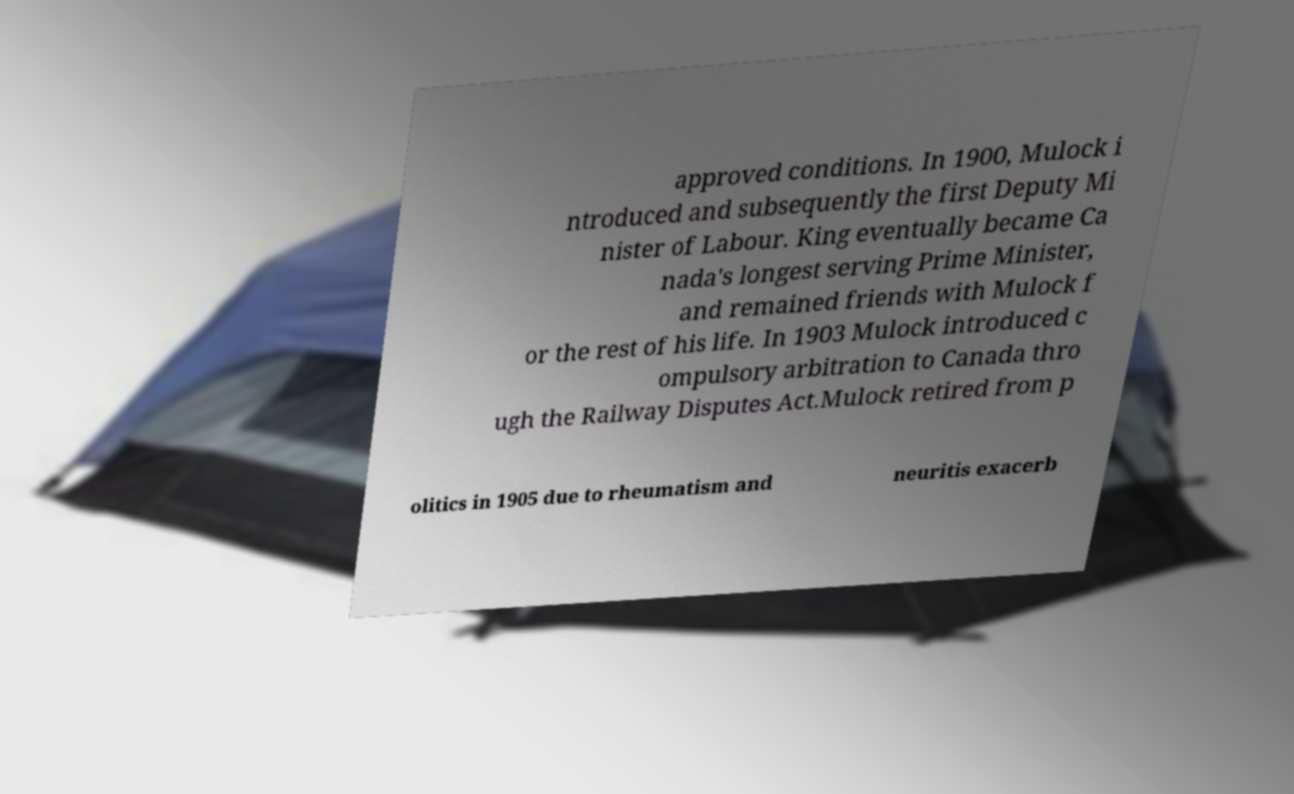Can you accurately transcribe the text from the provided image for me? approved conditions. In 1900, Mulock i ntroduced and subsequently the first Deputy Mi nister of Labour. King eventually became Ca nada's longest serving Prime Minister, and remained friends with Mulock f or the rest of his life. In 1903 Mulock introduced c ompulsory arbitration to Canada thro ugh the Railway Disputes Act.Mulock retired from p olitics in 1905 due to rheumatism and neuritis exacerb 